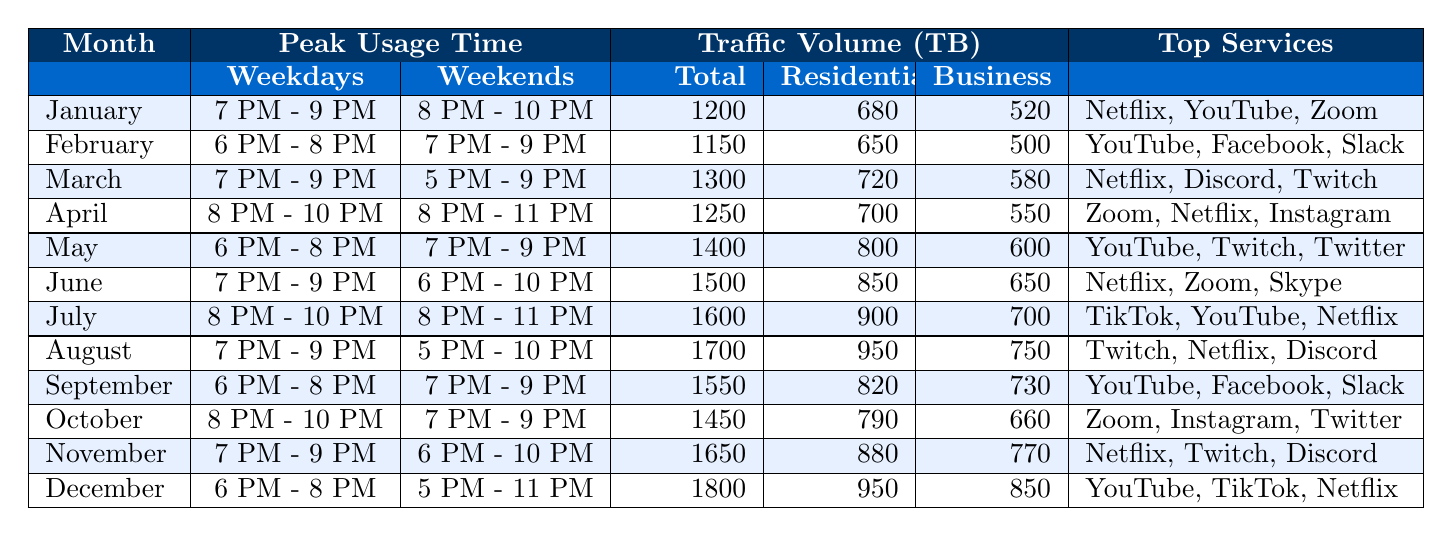What is the total traffic volume in December? The total traffic volume for December is listed directly in the table under the "Traffic Volume (TB)" section. According to the table, the total for December is 1800 TB.
Answer: 1800 TB In which month was the highest residential traffic recorded? By checking the "Residential" traffic volumes across all months, we find that December has the highest residential traffic at 950 TB.
Answer: December What was the weekend peak usage time in October? The table shows the "Peak Usage Time" for October under "Weekends" as "7 PM - 9 PM."
Answer: 7 PM - 9 PM How much more business traffic was there in July compared to January? The business traffic for July is 700 TB, and for January, it is 520 TB. The difference is calculated as 700 - 520 = 180 TB.
Answer: 180 TB What was the average total traffic volume from January to March? The total traffic volumes for January, February, and March are 1200, 1150, and 1300 TB, respectively. The sum is 1200 + 1150 + 1300 = 3650 TB. The average is then 3650 / 3 = 1216.67 TB.
Answer: 1216.67 TB True or False: The total traffic volume decreased from May to June. Comparing the total traffic for May (1400 TB) and June (1500 TB), we see that traffic actually increased from May to June instead of decreasing.
Answer: False Which month had the most popular service as "Netflix"? By examining the "Top Services Used" in each month, we identify that Netflix appears in January, March, April, June, July, November, and December. It is used in the highest number of months, thus confirmed as a popular service.
Answer: Multiple months What is the total traffic volume for business users across all months? By summing the "Business" traffic volumes for each month: 520 (Jan) + 500 (Feb) + 580 (Mar) + 550 (Apr) + 600 (May) + 650 (Jun) + 700 (Jul) + 750 (Aug) + 730 (Sep) + 660 (Oct) + 770 (Nov) + 850 (Dec) =  7300 TB.
Answer: 7300 TB Which month had the longest peak usage time during weekends? Reviewing the "Peak Usage Time" during weekends, April has the longest at "8 PM - 11 PM," making it the month with the longest peak.
Answer: April What percentage of the total traffic in June was from residential users? In June, the total traffic is 1500 TB and residential traffic is 850 TB. The percentage calculation is (850 / 1500) * 100 = 56.67%.
Answer: 56.67% 